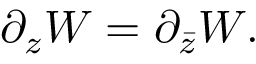Convert formula to latex. <formula><loc_0><loc_0><loc_500><loc_500>\partial _ { z } W = \partial _ { \bar { z } } W .</formula> 